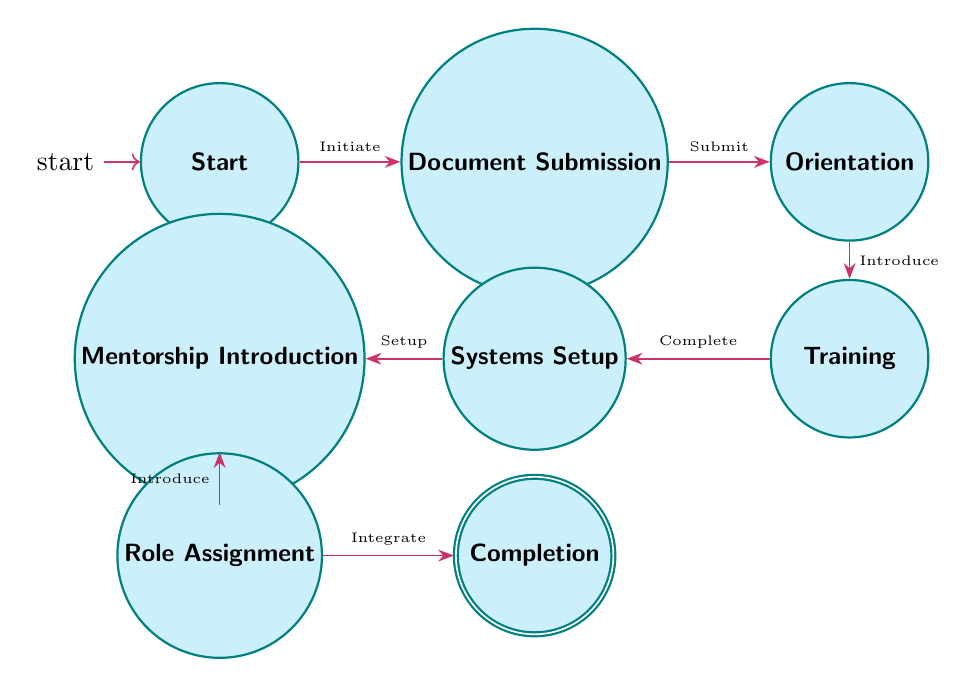What is the initial state in the onboarding process? The diagram indicates the starting point of the onboarding process, labeled as "Start."
Answer: Start How many states are there in the diagram? By counting the distinct labeled nodes in the diagram, we see there are a total of eight states.
Answer: Eight What state comes after "Document Submission"? The transition indicates that after submitting documents, the next step in the process is "Orientation."
Answer: Orientation What must be completed before moving to "Systems Setup"? The diagram shows that "Training" must be completed before transitioning to "Systems Setup."
Answer: Training Which state follows "Mentorship Introduction"? According to the transitions, the state that comes after "Mentorship Introduction" is "Role Assignment."
Answer: Role Assignment What state indicates the end of the onboarding process? The final state that signifies the completion of the onboarding process is labeled "Completion."
Answer: Completion What triggers the transition from "Start" to "Document Submission"? The diagram specifies that the initiation of the onboarding process triggers the movement from "Start" to "Document Submission."
Answer: Initiate How does a new employee reach the "Completion" state? To reach "Completion," an employee must successfully transition through the states: Document Submission, Orientation, Training, Systems Setup, Mentorship Introduction, and Role Assignment in sequence.
Answer: By completing all previous states What precedes the "Role Assignment" state? "Mentorship Introduction" directly precedes the current state, showing it as the prior step on the path to "Role Assignment."
Answer: Mentorship Introduction 